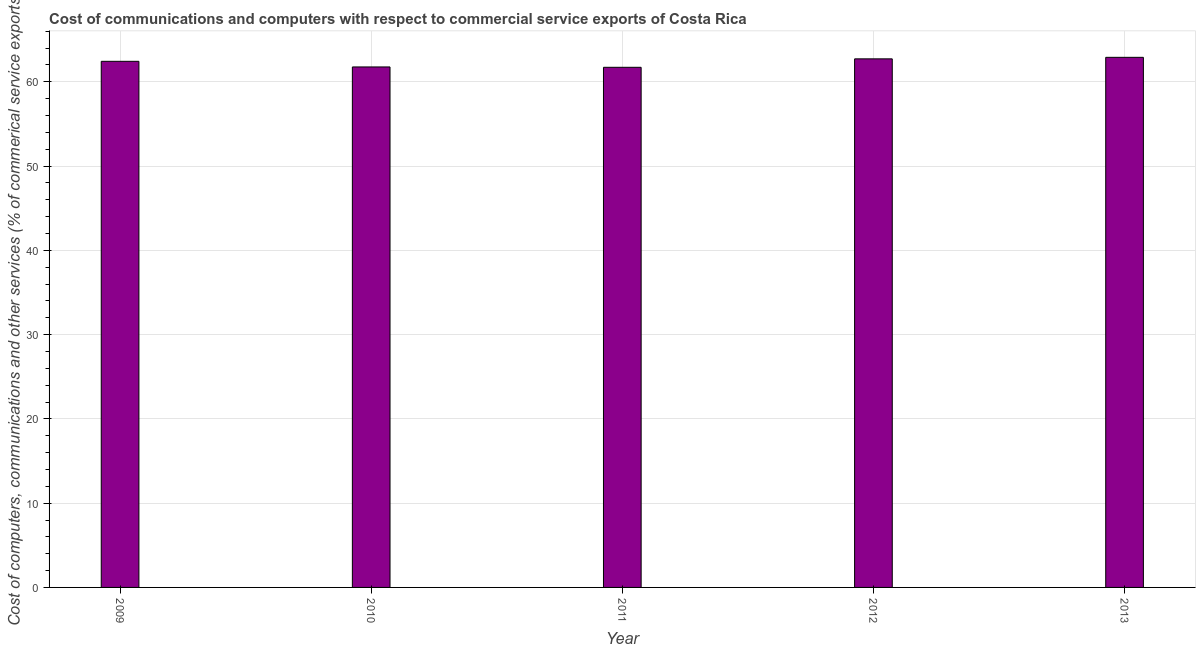Does the graph contain any zero values?
Keep it short and to the point. No. What is the title of the graph?
Your response must be concise. Cost of communications and computers with respect to commercial service exports of Costa Rica. What is the label or title of the Y-axis?
Keep it short and to the point. Cost of computers, communications and other services (% of commerical service exports). What is the cost of communications in 2011?
Ensure brevity in your answer.  61.72. Across all years, what is the maximum cost of communications?
Keep it short and to the point. 62.91. Across all years, what is the minimum  computer and other services?
Keep it short and to the point. 61.72. In which year was the cost of communications minimum?
Your answer should be very brief. 2011. What is the sum of the cost of communications?
Provide a succinct answer. 311.55. What is the difference between the  computer and other services in 2009 and 2013?
Your answer should be compact. -0.47. What is the average cost of communications per year?
Ensure brevity in your answer.  62.31. What is the median cost of communications?
Provide a short and direct response. 62.43. In how many years, is the  computer and other services greater than 26 %?
Offer a terse response. 5. What is the ratio of the  computer and other services in 2010 to that in 2012?
Provide a short and direct response. 0.98. Is the difference between the cost of communications in 2011 and 2012 greater than the difference between any two years?
Provide a succinct answer. No. What is the difference between the highest and the second highest  computer and other services?
Offer a terse response. 0.18. Is the sum of the  computer and other services in 2009 and 2012 greater than the maximum  computer and other services across all years?
Give a very brief answer. Yes. What is the difference between the highest and the lowest cost of communications?
Offer a very short reply. 1.18. In how many years, is the  computer and other services greater than the average  computer and other services taken over all years?
Keep it short and to the point. 3. What is the difference between two consecutive major ticks on the Y-axis?
Provide a short and direct response. 10. Are the values on the major ticks of Y-axis written in scientific E-notation?
Offer a very short reply. No. What is the Cost of computers, communications and other services (% of commerical service exports) of 2009?
Offer a terse response. 62.43. What is the Cost of computers, communications and other services (% of commerical service exports) of 2010?
Offer a very short reply. 61.76. What is the Cost of computers, communications and other services (% of commerical service exports) in 2011?
Your response must be concise. 61.72. What is the Cost of computers, communications and other services (% of commerical service exports) of 2012?
Your response must be concise. 62.72. What is the Cost of computers, communications and other services (% of commerical service exports) in 2013?
Your answer should be compact. 62.91. What is the difference between the Cost of computers, communications and other services (% of commerical service exports) in 2009 and 2010?
Your answer should be very brief. 0.67. What is the difference between the Cost of computers, communications and other services (% of commerical service exports) in 2009 and 2011?
Ensure brevity in your answer.  0.71. What is the difference between the Cost of computers, communications and other services (% of commerical service exports) in 2009 and 2012?
Make the answer very short. -0.29. What is the difference between the Cost of computers, communications and other services (% of commerical service exports) in 2009 and 2013?
Offer a very short reply. -0.47. What is the difference between the Cost of computers, communications and other services (% of commerical service exports) in 2010 and 2011?
Give a very brief answer. 0.04. What is the difference between the Cost of computers, communications and other services (% of commerical service exports) in 2010 and 2012?
Provide a short and direct response. -0.96. What is the difference between the Cost of computers, communications and other services (% of commerical service exports) in 2010 and 2013?
Give a very brief answer. -1.14. What is the difference between the Cost of computers, communications and other services (% of commerical service exports) in 2011 and 2012?
Your response must be concise. -1. What is the difference between the Cost of computers, communications and other services (% of commerical service exports) in 2011 and 2013?
Your answer should be compact. -1.18. What is the difference between the Cost of computers, communications and other services (% of commerical service exports) in 2012 and 2013?
Provide a short and direct response. -0.18. What is the ratio of the Cost of computers, communications and other services (% of commerical service exports) in 2009 to that in 2010?
Your answer should be very brief. 1.01. What is the ratio of the Cost of computers, communications and other services (% of commerical service exports) in 2009 to that in 2011?
Provide a succinct answer. 1.01. What is the ratio of the Cost of computers, communications and other services (% of commerical service exports) in 2009 to that in 2012?
Your answer should be compact. 0.99. What is the ratio of the Cost of computers, communications and other services (% of commerical service exports) in 2010 to that in 2011?
Keep it short and to the point. 1. What is the ratio of the Cost of computers, communications and other services (% of commerical service exports) in 2010 to that in 2013?
Your answer should be very brief. 0.98. What is the ratio of the Cost of computers, communications and other services (% of commerical service exports) in 2011 to that in 2013?
Provide a succinct answer. 0.98. What is the ratio of the Cost of computers, communications and other services (% of commerical service exports) in 2012 to that in 2013?
Your answer should be very brief. 1. 